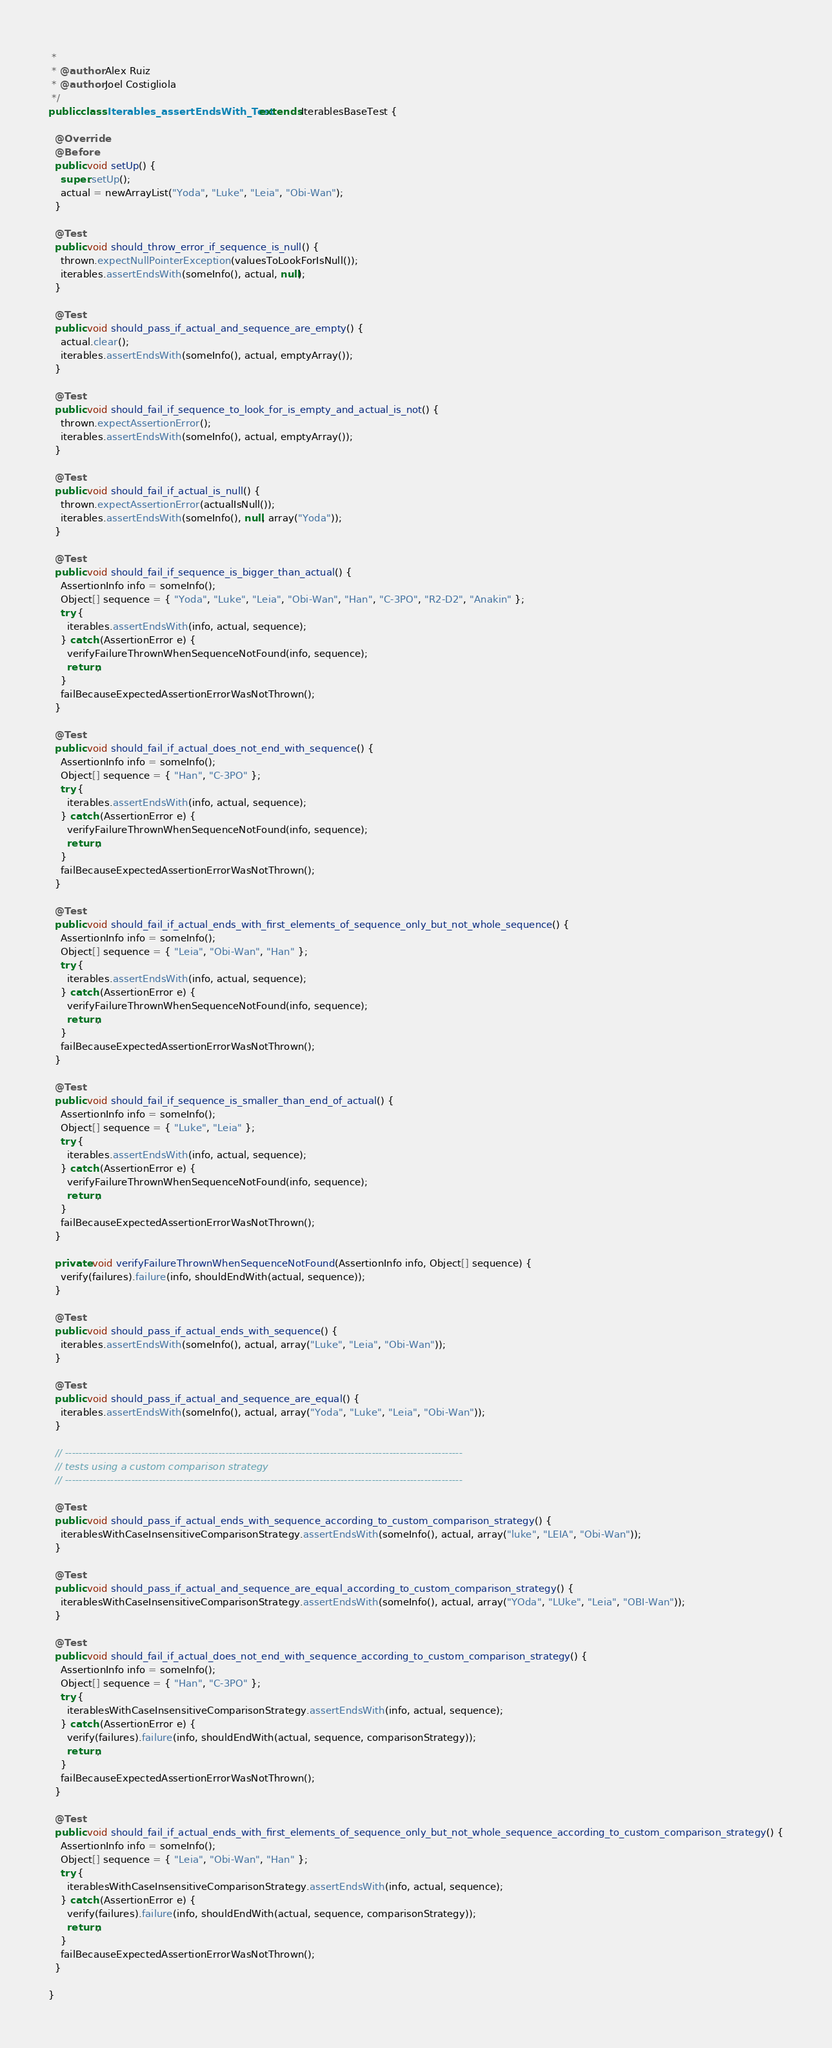Convert code to text. <code><loc_0><loc_0><loc_500><loc_500><_Java_> * 
 * @author Alex Ruiz
 * @author Joel Costigliola
 */
public class Iterables_assertEndsWith_Test extends IterablesBaseTest {

  @Override
  @Before
  public void setUp() {
    super.setUp();
    actual = newArrayList("Yoda", "Luke", "Leia", "Obi-Wan");
  }

  @Test
  public void should_throw_error_if_sequence_is_null() {
    thrown.expectNullPointerException(valuesToLookForIsNull());
    iterables.assertEndsWith(someInfo(), actual, null);
  }

  @Test
  public void should_pass_if_actual_and_sequence_are_empty() {
    actual.clear();
    iterables.assertEndsWith(someInfo(), actual, emptyArray());
  }
  
  @Test
  public void should_fail_if_sequence_to_look_for_is_empty_and_actual_is_not() {
    thrown.expectAssertionError();
    iterables.assertEndsWith(someInfo(), actual, emptyArray());
  }

  @Test
  public void should_fail_if_actual_is_null() {
    thrown.expectAssertionError(actualIsNull());
    iterables.assertEndsWith(someInfo(), null, array("Yoda"));
  }

  @Test
  public void should_fail_if_sequence_is_bigger_than_actual() {
    AssertionInfo info = someInfo();
    Object[] sequence = { "Yoda", "Luke", "Leia", "Obi-Wan", "Han", "C-3PO", "R2-D2", "Anakin" };
    try {
      iterables.assertEndsWith(info, actual, sequence);
    } catch (AssertionError e) {
      verifyFailureThrownWhenSequenceNotFound(info, sequence);
      return;
    }
    failBecauseExpectedAssertionErrorWasNotThrown();
  }

  @Test
  public void should_fail_if_actual_does_not_end_with_sequence() {
    AssertionInfo info = someInfo();
    Object[] sequence = { "Han", "C-3PO" };
    try {
      iterables.assertEndsWith(info, actual, sequence);
    } catch (AssertionError e) {
      verifyFailureThrownWhenSequenceNotFound(info, sequence);
      return;
    }
    failBecauseExpectedAssertionErrorWasNotThrown();
  }

  @Test
  public void should_fail_if_actual_ends_with_first_elements_of_sequence_only_but_not_whole_sequence() {
    AssertionInfo info = someInfo();
    Object[] sequence = { "Leia", "Obi-Wan", "Han" };
    try {
      iterables.assertEndsWith(info, actual, sequence);
    } catch (AssertionError e) {
      verifyFailureThrownWhenSequenceNotFound(info, sequence);
      return;
    }
    failBecauseExpectedAssertionErrorWasNotThrown();
  }

  @Test
  public void should_fail_if_sequence_is_smaller_than_end_of_actual() {
    AssertionInfo info = someInfo();
    Object[] sequence = { "Luke", "Leia" };
    try {
      iterables.assertEndsWith(info, actual, sequence);
    } catch (AssertionError e) {
      verifyFailureThrownWhenSequenceNotFound(info, sequence);
      return;
    }
    failBecauseExpectedAssertionErrorWasNotThrown();
  }

  private void verifyFailureThrownWhenSequenceNotFound(AssertionInfo info, Object[] sequence) {
    verify(failures).failure(info, shouldEndWith(actual, sequence));
  }

  @Test
  public void should_pass_if_actual_ends_with_sequence() {
    iterables.assertEndsWith(someInfo(), actual, array("Luke", "Leia", "Obi-Wan"));
  }

  @Test
  public void should_pass_if_actual_and_sequence_are_equal() {
    iterables.assertEndsWith(someInfo(), actual, array("Yoda", "Luke", "Leia", "Obi-Wan"));
  }

  // ------------------------------------------------------------------------------------------------------------------
  // tests using a custom comparison strategy
  // ------------------------------------------------------------------------------------------------------------------

  @Test
  public void should_pass_if_actual_ends_with_sequence_according_to_custom_comparison_strategy() {
    iterablesWithCaseInsensitiveComparisonStrategy.assertEndsWith(someInfo(), actual, array("luke", "LEIA", "Obi-Wan"));
  }

  @Test
  public void should_pass_if_actual_and_sequence_are_equal_according_to_custom_comparison_strategy() {
    iterablesWithCaseInsensitiveComparisonStrategy.assertEndsWith(someInfo(), actual, array("YOda", "LUke", "Leia", "OBI-Wan"));
  }

  @Test
  public void should_fail_if_actual_does_not_end_with_sequence_according_to_custom_comparison_strategy() {
    AssertionInfo info = someInfo();
    Object[] sequence = { "Han", "C-3PO" };
    try {
      iterablesWithCaseInsensitiveComparisonStrategy.assertEndsWith(info, actual, sequence);
    } catch (AssertionError e) {
      verify(failures).failure(info, shouldEndWith(actual, sequence, comparisonStrategy));
      return;
    }
    failBecauseExpectedAssertionErrorWasNotThrown();
  }

  @Test
  public void should_fail_if_actual_ends_with_first_elements_of_sequence_only_but_not_whole_sequence_according_to_custom_comparison_strategy() {
    AssertionInfo info = someInfo();
    Object[] sequence = { "Leia", "Obi-Wan", "Han" };
    try {
      iterablesWithCaseInsensitiveComparisonStrategy.assertEndsWith(info, actual, sequence);
    } catch (AssertionError e) {
      verify(failures).failure(info, shouldEndWith(actual, sequence, comparisonStrategy));
      return;
    }
    failBecauseExpectedAssertionErrorWasNotThrown();
  }

}
</code> 